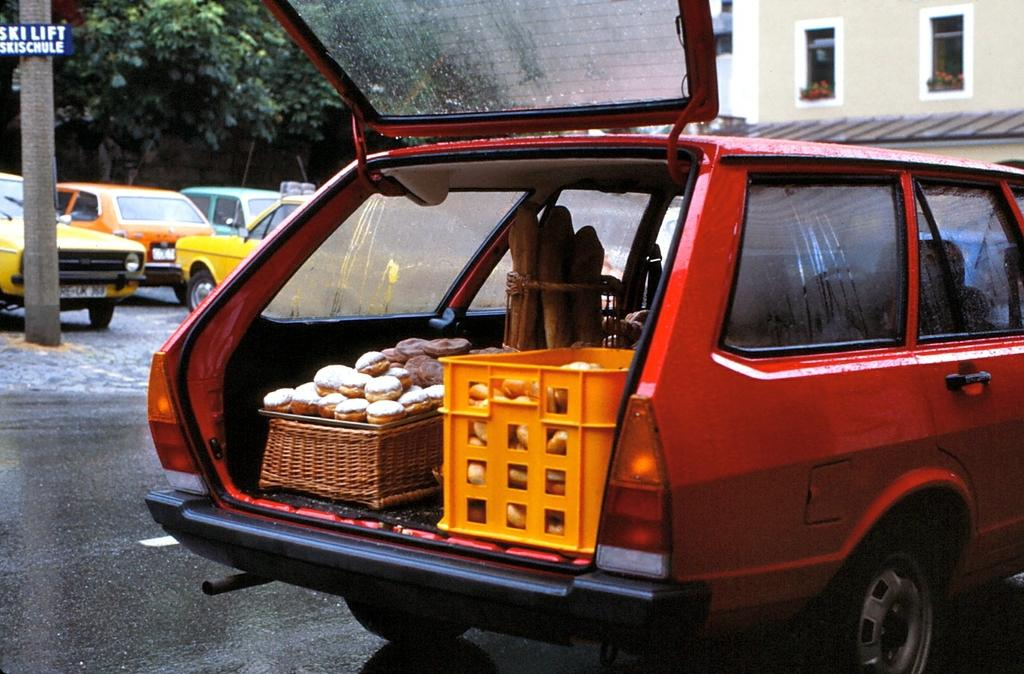<image>
Render a clear and concise summary of the photo. The sign post has skischule written on the bottom. 